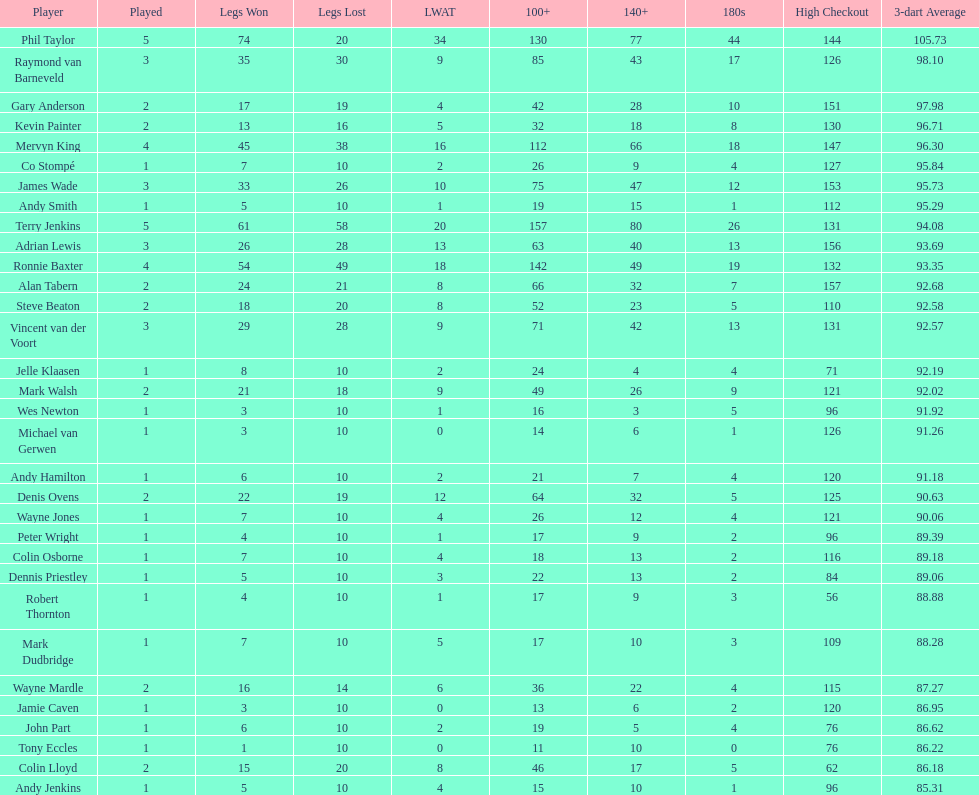What is the number of players with a 3-dart average exceeding 97? 3. 